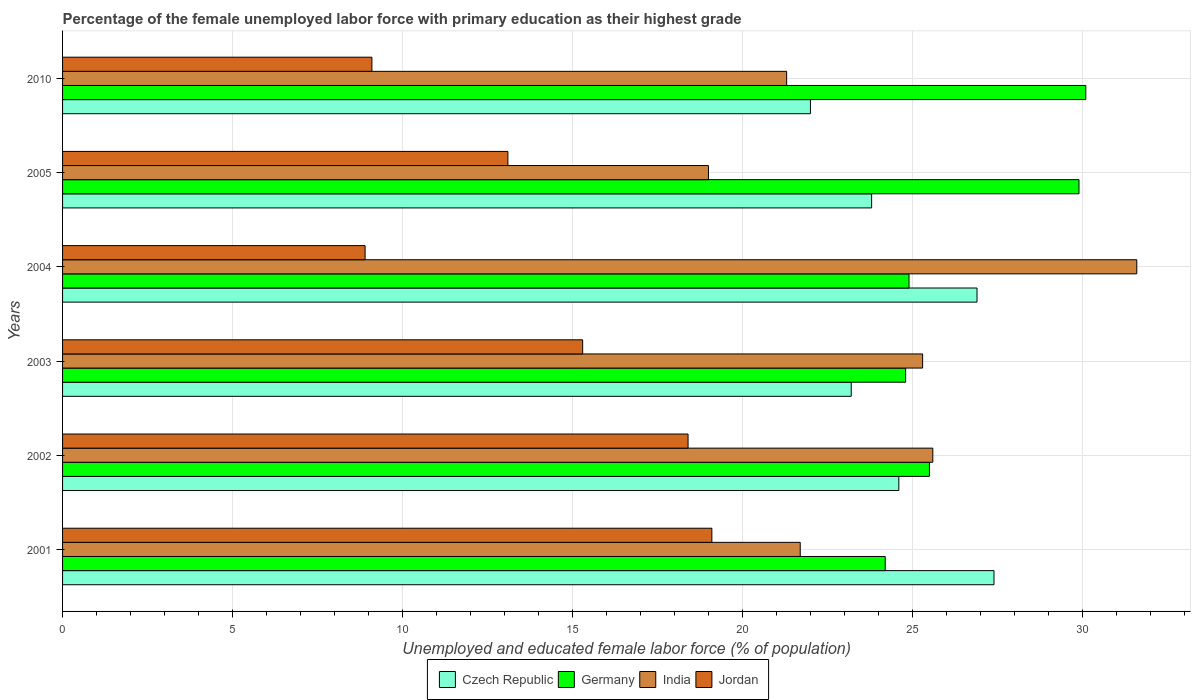How many groups of bars are there?
Your answer should be very brief. 6. Are the number of bars per tick equal to the number of legend labels?
Provide a short and direct response. Yes. Are the number of bars on each tick of the Y-axis equal?
Offer a very short reply. Yes. How many bars are there on the 5th tick from the top?
Offer a very short reply. 4. What is the label of the 1st group of bars from the top?
Your answer should be very brief. 2010. What is the percentage of the unemployed female labor force with primary education in Czech Republic in 2004?
Give a very brief answer. 26.9. Across all years, what is the maximum percentage of the unemployed female labor force with primary education in Germany?
Your answer should be compact. 30.1. In which year was the percentage of the unemployed female labor force with primary education in Germany maximum?
Your response must be concise. 2010. In which year was the percentage of the unemployed female labor force with primary education in India minimum?
Ensure brevity in your answer.  2005. What is the total percentage of the unemployed female labor force with primary education in Jordan in the graph?
Give a very brief answer. 83.9. What is the difference between the percentage of the unemployed female labor force with primary education in Germany in 2001 and that in 2010?
Provide a succinct answer. -5.9. What is the difference between the percentage of the unemployed female labor force with primary education in Czech Republic in 2004 and the percentage of the unemployed female labor force with primary education in Jordan in 2002?
Your answer should be compact. 8.5. What is the average percentage of the unemployed female labor force with primary education in Germany per year?
Offer a terse response. 26.57. In the year 2001, what is the difference between the percentage of the unemployed female labor force with primary education in Germany and percentage of the unemployed female labor force with primary education in Jordan?
Ensure brevity in your answer.  5.1. What is the ratio of the percentage of the unemployed female labor force with primary education in Czech Republic in 2004 to that in 2005?
Offer a very short reply. 1.13. What is the difference between the highest and the second highest percentage of the unemployed female labor force with primary education in Jordan?
Your answer should be very brief. 0.7. What is the difference between the highest and the lowest percentage of the unemployed female labor force with primary education in Germany?
Ensure brevity in your answer.  5.9. In how many years, is the percentage of the unemployed female labor force with primary education in Czech Republic greater than the average percentage of the unemployed female labor force with primary education in Czech Republic taken over all years?
Provide a succinct answer. 2. What does the 4th bar from the top in 2005 represents?
Offer a very short reply. Czech Republic. How many years are there in the graph?
Ensure brevity in your answer.  6. Are the values on the major ticks of X-axis written in scientific E-notation?
Offer a very short reply. No. Does the graph contain grids?
Your answer should be compact. Yes. Where does the legend appear in the graph?
Ensure brevity in your answer.  Bottom center. What is the title of the graph?
Make the answer very short. Percentage of the female unemployed labor force with primary education as their highest grade. What is the label or title of the X-axis?
Provide a succinct answer. Unemployed and educated female labor force (% of population). What is the Unemployed and educated female labor force (% of population) in Czech Republic in 2001?
Your answer should be very brief. 27.4. What is the Unemployed and educated female labor force (% of population) in Germany in 2001?
Ensure brevity in your answer.  24.2. What is the Unemployed and educated female labor force (% of population) in India in 2001?
Your answer should be very brief. 21.7. What is the Unemployed and educated female labor force (% of population) in Jordan in 2001?
Your answer should be compact. 19.1. What is the Unemployed and educated female labor force (% of population) of Czech Republic in 2002?
Your answer should be very brief. 24.6. What is the Unemployed and educated female labor force (% of population) of Germany in 2002?
Give a very brief answer. 25.5. What is the Unemployed and educated female labor force (% of population) of India in 2002?
Give a very brief answer. 25.6. What is the Unemployed and educated female labor force (% of population) in Jordan in 2002?
Give a very brief answer. 18.4. What is the Unemployed and educated female labor force (% of population) in Czech Republic in 2003?
Provide a short and direct response. 23.2. What is the Unemployed and educated female labor force (% of population) in Germany in 2003?
Give a very brief answer. 24.8. What is the Unemployed and educated female labor force (% of population) of India in 2003?
Make the answer very short. 25.3. What is the Unemployed and educated female labor force (% of population) of Jordan in 2003?
Provide a short and direct response. 15.3. What is the Unemployed and educated female labor force (% of population) of Czech Republic in 2004?
Keep it short and to the point. 26.9. What is the Unemployed and educated female labor force (% of population) in Germany in 2004?
Offer a terse response. 24.9. What is the Unemployed and educated female labor force (% of population) in India in 2004?
Make the answer very short. 31.6. What is the Unemployed and educated female labor force (% of population) of Jordan in 2004?
Ensure brevity in your answer.  8.9. What is the Unemployed and educated female labor force (% of population) of Czech Republic in 2005?
Give a very brief answer. 23.8. What is the Unemployed and educated female labor force (% of population) of Germany in 2005?
Offer a very short reply. 29.9. What is the Unemployed and educated female labor force (% of population) in India in 2005?
Your response must be concise. 19. What is the Unemployed and educated female labor force (% of population) of Jordan in 2005?
Your answer should be compact. 13.1. What is the Unemployed and educated female labor force (% of population) in Germany in 2010?
Provide a succinct answer. 30.1. What is the Unemployed and educated female labor force (% of population) in India in 2010?
Your answer should be very brief. 21.3. What is the Unemployed and educated female labor force (% of population) of Jordan in 2010?
Make the answer very short. 9.1. Across all years, what is the maximum Unemployed and educated female labor force (% of population) in Czech Republic?
Offer a very short reply. 27.4. Across all years, what is the maximum Unemployed and educated female labor force (% of population) in Germany?
Ensure brevity in your answer.  30.1. Across all years, what is the maximum Unemployed and educated female labor force (% of population) in India?
Provide a succinct answer. 31.6. Across all years, what is the maximum Unemployed and educated female labor force (% of population) of Jordan?
Make the answer very short. 19.1. Across all years, what is the minimum Unemployed and educated female labor force (% of population) in Germany?
Your answer should be compact. 24.2. Across all years, what is the minimum Unemployed and educated female labor force (% of population) in India?
Offer a very short reply. 19. Across all years, what is the minimum Unemployed and educated female labor force (% of population) of Jordan?
Your answer should be very brief. 8.9. What is the total Unemployed and educated female labor force (% of population) of Czech Republic in the graph?
Make the answer very short. 147.9. What is the total Unemployed and educated female labor force (% of population) of Germany in the graph?
Provide a short and direct response. 159.4. What is the total Unemployed and educated female labor force (% of population) in India in the graph?
Provide a short and direct response. 144.5. What is the total Unemployed and educated female labor force (% of population) in Jordan in the graph?
Ensure brevity in your answer.  83.9. What is the difference between the Unemployed and educated female labor force (% of population) of Czech Republic in 2001 and that in 2002?
Keep it short and to the point. 2.8. What is the difference between the Unemployed and educated female labor force (% of population) in Germany in 2001 and that in 2002?
Your answer should be compact. -1.3. What is the difference between the Unemployed and educated female labor force (% of population) in Jordan in 2001 and that in 2002?
Provide a short and direct response. 0.7. What is the difference between the Unemployed and educated female labor force (% of population) in Czech Republic in 2001 and that in 2003?
Make the answer very short. 4.2. What is the difference between the Unemployed and educated female labor force (% of population) in India in 2001 and that in 2003?
Give a very brief answer. -3.6. What is the difference between the Unemployed and educated female labor force (% of population) in Germany in 2001 and that in 2004?
Your answer should be very brief. -0.7. What is the difference between the Unemployed and educated female labor force (% of population) in Jordan in 2001 and that in 2004?
Make the answer very short. 10.2. What is the difference between the Unemployed and educated female labor force (% of population) of Czech Republic in 2001 and that in 2005?
Provide a short and direct response. 3.6. What is the difference between the Unemployed and educated female labor force (% of population) in Germany in 2001 and that in 2005?
Your answer should be compact. -5.7. What is the difference between the Unemployed and educated female labor force (% of population) in India in 2001 and that in 2005?
Make the answer very short. 2.7. What is the difference between the Unemployed and educated female labor force (% of population) in Czech Republic in 2001 and that in 2010?
Provide a short and direct response. 5.4. What is the difference between the Unemployed and educated female labor force (% of population) of Germany in 2001 and that in 2010?
Your answer should be compact. -5.9. What is the difference between the Unemployed and educated female labor force (% of population) of India in 2001 and that in 2010?
Your answer should be compact. 0.4. What is the difference between the Unemployed and educated female labor force (% of population) of Czech Republic in 2002 and that in 2003?
Your answer should be very brief. 1.4. What is the difference between the Unemployed and educated female labor force (% of population) in India in 2002 and that in 2003?
Your answer should be compact. 0.3. What is the difference between the Unemployed and educated female labor force (% of population) in Jordan in 2002 and that in 2003?
Offer a very short reply. 3.1. What is the difference between the Unemployed and educated female labor force (% of population) in Czech Republic in 2002 and that in 2004?
Give a very brief answer. -2.3. What is the difference between the Unemployed and educated female labor force (% of population) of Jordan in 2002 and that in 2004?
Offer a terse response. 9.5. What is the difference between the Unemployed and educated female labor force (% of population) of Czech Republic in 2002 and that in 2005?
Keep it short and to the point. 0.8. What is the difference between the Unemployed and educated female labor force (% of population) of Jordan in 2002 and that in 2005?
Provide a short and direct response. 5.3. What is the difference between the Unemployed and educated female labor force (% of population) in Germany in 2002 and that in 2010?
Your answer should be compact. -4.6. What is the difference between the Unemployed and educated female labor force (% of population) in Jordan in 2002 and that in 2010?
Give a very brief answer. 9.3. What is the difference between the Unemployed and educated female labor force (% of population) of Germany in 2003 and that in 2004?
Make the answer very short. -0.1. What is the difference between the Unemployed and educated female labor force (% of population) in Jordan in 2003 and that in 2004?
Provide a succinct answer. 6.4. What is the difference between the Unemployed and educated female labor force (% of population) of Germany in 2003 and that in 2005?
Offer a terse response. -5.1. What is the difference between the Unemployed and educated female labor force (% of population) of India in 2003 and that in 2010?
Offer a very short reply. 4. What is the difference between the Unemployed and educated female labor force (% of population) of Germany in 2004 and that in 2005?
Your answer should be compact. -5. What is the difference between the Unemployed and educated female labor force (% of population) in India in 2004 and that in 2005?
Ensure brevity in your answer.  12.6. What is the difference between the Unemployed and educated female labor force (% of population) of Germany in 2004 and that in 2010?
Give a very brief answer. -5.2. What is the difference between the Unemployed and educated female labor force (% of population) in Jordan in 2004 and that in 2010?
Keep it short and to the point. -0.2. What is the difference between the Unemployed and educated female labor force (% of population) of Czech Republic in 2005 and that in 2010?
Keep it short and to the point. 1.8. What is the difference between the Unemployed and educated female labor force (% of population) in Czech Republic in 2001 and the Unemployed and educated female labor force (% of population) in India in 2002?
Your response must be concise. 1.8. What is the difference between the Unemployed and educated female labor force (% of population) of Germany in 2001 and the Unemployed and educated female labor force (% of population) of Jordan in 2002?
Provide a succinct answer. 5.8. What is the difference between the Unemployed and educated female labor force (% of population) in India in 2001 and the Unemployed and educated female labor force (% of population) in Jordan in 2002?
Your answer should be compact. 3.3. What is the difference between the Unemployed and educated female labor force (% of population) in Czech Republic in 2001 and the Unemployed and educated female labor force (% of population) in Germany in 2003?
Your answer should be very brief. 2.6. What is the difference between the Unemployed and educated female labor force (% of population) in Czech Republic in 2001 and the Unemployed and educated female labor force (% of population) in India in 2003?
Offer a very short reply. 2.1. What is the difference between the Unemployed and educated female labor force (% of population) in Germany in 2001 and the Unemployed and educated female labor force (% of population) in India in 2003?
Provide a succinct answer. -1.1. What is the difference between the Unemployed and educated female labor force (% of population) of India in 2001 and the Unemployed and educated female labor force (% of population) of Jordan in 2003?
Make the answer very short. 6.4. What is the difference between the Unemployed and educated female labor force (% of population) of Czech Republic in 2001 and the Unemployed and educated female labor force (% of population) of Jordan in 2004?
Give a very brief answer. 18.5. What is the difference between the Unemployed and educated female labor force (% of population) in Germany in 2001 and the Unemployed and educated female labor force (% of population) in India in 2004?
Ensure brevity in your answer.  -7.4. What is the difference between the Unemployed and educated female labor force (% of population) of Germany in 2001 and the Unemployed and educated female labor force (% of population) of Jordan in 2004?
Make the answer very short. 15.3. What is the difference between the Unemployed and educated female labor force (% of population) in Czech Republic in 2001 and the Unemployed and educated female labor force (% of population) in Germany in 2005?
Provide a short and direct response. -2.5. What is the difference between the Unemployed and educated female labor force (% of population) in Germany in 2001 and the Unemployed and educated female labor force (% of population) in Jordan in 2005?
Offer a very short reply. 11.1. What is the difference between the Unemployed and educated female labor force (% of population) of Czech Republic in 2001 and the Unemployed and educated female labor force (% of population) of India in 2010?
Offer a terse response. 6.1. What is the difference between the Unemployed and educated female labor force (% of population) of Czech Republic in 2001 and the Unemployed and educated female labor force (% of population) of Jordan in 2010?
Your answer should be compact. 18.3. What is the difference between the Unemployed and educated female labor force (% of population) in Germany in 2001 and the Unemployed and educated female labor force (% of population) in India in 2010?
Provide a succinct answer. 2.9. What is the difference between the Unemployed and educated female labor force (% of population) in Germany in 2001 and the Unemployed and educated female labor force (% of population) in Jordan in 2010?
Provide a short and direct response. 15.1. What is the difference between the Unemployed and educated female labor force (% of population) of Czech Republic in 2002 and the Unemployed and educated female labor force (% of population) of Germany in 2003?
Make the answer very short. -0.2. What is the difference between the Unemployed and educated female labor force (% of population) of Czech Republic in 2002 and the Unemployed and educated female labor force (% of population) of India in 2003?
Your answer should be compact. -0.7. What is the difference between the Unemployed and educated female labor force (% of population) of Germany in 2002 and the Unemployed and educated female labor force (% of population) of India in 2003?
Provide a succinct answer. 0.2. What is the difference between the Unemployed and educated female labor force (% of population) of India in 2002 and the Unemployed and educated female labor force (% of population) of Jordan in 2003?
Your response must be concise. 10.3. What is the difference between the Unemployed and educated female labor force (% of population) of Czech Republic in 2002 and the Unemployed and educated female labor force (% of population) of India in 2004?
Your response must be concise. -7. What is the difference between the Unemployed and educated female labor force (% of population) in Czech Republic in 2002 and the Unemployed and educated female labor force (% of population) in Jordan in 2004?
Provide a short and direct response. 15.7. What is the difference between the Unemployed and educated female labor force (% of population) of Germany in 2002 and the Unemployed and educated female labor force (% of population) of India in 2004?
Make the answer very short. -6.1. What is the difference between the Unemployed and educated female labor force (% of population) in Czech Republic in 2002 and the Unemployed and educated female labor force (% of population) in Germany in 2005?
Provide a short and direct response. -5.3. What is the difference between the Unemployed and educated female labor force (% of population) in Czech Republic in 2002 and the Unemployed and educated female labor force (% of population) in Jordan in 2005?
Give a very brief answer. 11.5. What is the difference between the Unemployed and educated female labor force (% of population) of Germany in 2002 and the Unemployed and educated female labor force (% of population) of Jordan in 2005?
Provide a short and direct response. 12.4. What is the difference between the Unemployed and educated female labor force (% of population) of Germany in 2002 and the Unemployed and educated female labor force (% of population) of Jordan in 2010?
Your answer should be very brief. 16.4. What is the difference between the Unemployed and educated female labor force (% of population) in Czech Republic in 2003 and the Unemployed and educated female labor force (% of population) in India in 2004?
Provide a succinct answer. -8.4. What is the difference between the Unemployed and educated female labor force (% of population) in Czech Republic in 2003 and the Unemployed and educated female labor force (% of population) in Jordan in 2004?
Ensure brevity in your answer.  14.3. What is the difference between the Unemployed and educated female labor force (% of population) in Germany in 2003 and the Unemployed and educated female labor force (% of population) in India in 2004?
Provide a succinct answer. -6.8. What is the difference between the Unemployed and educated female labor force (% of population) of India in 2003 and the Unemployed and educated female labor force (% of population) of Jordan in 2004?
Make the answer very short. 16.4. What is the difference between the Unemployed and educated female labor force (% of population) of Czech Republic in 2003 and the Unemployed and educated female labor force (% of population) of Jordan in 2005?
Your answer should be compact. 10.1. What is the difference between the Unemployed and educated female labor force (% of population) of Germany in 2003 and the Unemployed and educated female labor force (% of population) of India in 2005?
Your answer should be compact. 5.8. What is the difference between the Unemployed and educated female labor force (% of population) of Czech Republic in 2003 and the Unemployed and educated female labor force (% of population) of Germany in 2010?
Keep it short and to the point. -6.9. What is the difference between the Unemployed and educated female labor force (% of population) of Czech Republic in 2003 and the Unemployed and educated female labor force (% of population) of India in 2010?
Ensure brevity in your answer.  1.9. What is the difference between the Unemployed and educated female labor force (% of population) of Germany in 2003 and the Unemployed and educated female labor force (% of population) of India in 2010?
Keep it short and to the point. 3.5. What is the difference between the Unemployed and educated female labor force (% of population) of India in 2003 and the Unemployed and educated female labor force (% of population) of Jordan in 2010?
Offer a very short reply. 16.2. What is the difference between the Unemployed and educated female labor force (% of population) of Czech Republic in 2004 and the Unemployed and educated female labor force (% of population) of India in 2005?
Keep it short and to the point. 7.9. What is the difference between the Unemployed and educated female labor force (% of population) in India in 2004 and the Unemployed and educated female labor force (% of population) in Jordan in 2005?
Your answer should be very brief. 18.5. What is the difference between the Unemployed and educated female labor force (% of population) of Czech Republic in 2004 and the Unemployed and educated female labor force (% of population) of Germany in 2010?
Keep it short and to the point. -3.2. What is the difference between the Unemployed and educated female labor force (% of population) in Germany in 2004 and the Unemployed and educated female labor force (% of population) in India in 2010?
Your answer should be compact. 3.6. What is the difference between the Unemployed and educated female labor force (% of population) in Germany in 2004 and the Unemployed and educated female labor force (% of population) in Jordan in 2010?
Give a very brief answer. 15.8. What is the difference between the Unemployed and educated female labor force (% of population) of Czech Republic in 2005 and the Unemployed and educated female labor force (% of population) of Germany in 2010?
Provide a short and direct response. -6.3. What is the difference between the Unemployed and educated female labor force (% of population) of Germany in 2005 and the Unemployed and educated female labor force (% of population) of Jordan in 2010?
Offer a very short reply. 20.8. What is the average Unemployed and educated female labor force (% of population) in Czech Republic per year?
Offer a very short reply. 24.65. What is the average Unemployed and educated female labor force (% of population) of Germany per year?
Offer a very short reply. 26.57. What is the average Unemployed and educated female labor force (% of population) in India per year?
Your response must be concise. 24.08. What is the average Unemployed and educated female labor force (% of population) of Jordan per year?
Your answer should be compact. 13.98. In the year 2001, what is the difference between the Unemployed and educated female labor force (% of population) in Czech Republic and Unemployed and educated female labor force (% of population) in India?
Give a very brief answer. 5.7. In the year 2001, what is the difference between the Unemployed and educated female labor force (% of population) of Germany and Unemployed and educated female labor force (% of population) of India?
Give a very brief answer. 2.5. In the year 2001, what is the difference between the Unemployed and educated female labor force (% of population) in India and Unemployed and educated female labor force (% of population) in Jordan?
Provide a short and direct response. 2.6. In the year 2002, what is the difference between the Unemployed and educated female labor force (% of population) of Czech Republic and Unemployed and educated female labor force (% of population) of Germany?
Keep it short and to the point. -0.9. In the year 2002, what is the difference between the Unemployed and educated female labor force (% of population) in Czech Republic and Unemployed and educated female labor force (% of population) in India?
Offer a terse response. -1. In the year 2002, what is the difference between the Unemployed and educated female labor force (% of population) of Czech Republic and Unemployed and educated female labor force (% of population) of Jordan?
Your response must be concise. 6.2. In the year 2002, what is the difference between the Unemployed and educated female labor force (% of population) of Germany and Unemployed and educated female labor force (% of population) of India?
Keep it short and to the point. -0.1. In the year 2002, what is the difference between the Unemployed and educated female labor force (% of population) in India and Unemployed and educated female labor force (% of population) in Jordan?
Give a very brief answer. 7.2. In the year 2003, what is the difference between the Unemployed and educated female labor force (% of population) of Czech Republic and Unemployed and educated female labor force (% of population) of Germany?
Make the answer very short. -1.6. In the year 2003, what is the difference between the Unemployed and educated female labor force (% of population) in Czech Republic and Unemployed and educated female labor force (% of population) in Jordan?
Your response must be concise. 7.9. In the year 2004, what is the difference between the Unemployed and educated female labor force (% of population) in Czech Republic and Unemployed and educated female labor force (% of population) in Germany?
Offer a very short reply. 2. In the year 2004, what is the difference between the Unemployed and educated female labor force (% of population) of Germany and Unemployed and educated female labor force (% of population) of India?
Your response must be concise. -6.7. In the year 2004, what is the difference between the Unemployed and educated female labor force (% of population) in Germany and Unemployed and educated female labor force (% of population) in Jordan?
Provide a succinct answer. 16. In the year 2004, what is the difference between the Unemployed and educated female labor force (% of population) in India and Unemployed and educated female labor force (% of population) in Jordan?
Your answer should be compact. 22.7. In the year 2005, what is the difference between the Unemployed and educated female labor force (% of population) of Germany and Unemployed and educated female labor force (% of population) of India?
Provide a short and direct response. 10.9. In the year 2010, what is the difference between the Unemployed and educated female labor force (% of population) of Czech Republic and Unemployed and educated female labor force (% of population) of Germany?
Ensure brevity in your answer.  -8.1. In the year 2010, what is the difference between the Unemployed and educated female labor force (% of population) of Czech Republic and Unemployed and educated female labor force (% of population) of India?
Offer a terse response. 0.7. In the year 2010, what is the difference between the Unemployed and educated female labor force (% of population) of Germany and Unemployed and educated female labor force (% of population) of India?
Provide a succinct answer. 8.8. What is the ratio of the Unemployed and educated female labor force (% of population) in Czech Republic in 2001 to that in 2002?
Your response must be concise. 1.11. What is the ratio of the Unemployed and educated female labor force (% of population) of Germany in 2001 to that in 2002?
Provide a short and direct response. 0.95. What is the ratio of the Unemployed and educated female labor force (% of population) in India in 2001 to that in 2002?
Your response must be concise. 0.85. What is the ratio of the Unemployed and educated female labor force (% of population) in Jordan in 2001 to that in 2002?
Give a very brief answer. 1.04. What is the ratio of the Unemployed and educated female labor force (% of population) in Czech Republic in 2001 to that in 2003?
Offer a terse response. 1.18. What is the ratio of the Unemployed and educated female labor force (% of population) of Germany in 2001 to that in 2003?
Ensure brevity in your answer.  0.98. What is the ratio of the Unemployed and educated female labor force (% of population) in India in 2001 to that in 2003?
Make the answer very short. 0.86. What is the ratio of the Unemployed and educated female labor force (% of population) in Jordan in 2001 to that in 2003?
Your response must be concise. 1.25. What is the ratio of the Unemployed and educated female labor force (% of population) of Czech Republic in 2001 to that in 2004?
Your answer should be compact. 1.02. What is the ratio of the Unemployed and educated female labor force (% of population) of Germany in 2001 to that in 2004?
Your answer should be compact. 0.97. What is the ratio of the Unemployed and educated female labor force (% of population) of India in 2001 to that in 2004?
Your answer should be compact. 0.69. What is the ratio of the Unemployed and educated female labor force (% of population) in Jordan in 2001 to that in 2004?
Provide a short and direct response. 2.15. What is the ratio of the Unemployed and educated female labor force (% of population) in Czech Republic in 2001 to that in 2005?
Ensure brevity in your answer.  1.15. What is the ratio of the Unemployed and educated female labor force (% of population) in Germany in 2001 to that in 2005?
Give a very brief answer. 0.81. What is the ratio of the Unemployed and educated female labor force (% of population) of India in 2001 to that in 2005?
Keep it short and to the point. 1.14. What is the ratio of the Unemployed and educated female labor force (% of population) of Jordan in 2001 to that in 2005?
Offer a very short reply. 1.46. What is the ratio of the Unemployed and educated female labor force (% of population) in Czech Republic in 2001 to that in 2010?
Provide a short and direct response. 1.25. What is the ratio of the Unemployed and educated female labor force (% of population) of Germany in 2001 to that in 2010?
Offer a terse response. 0.8. What is the ratio of the Unemployed and educated female labor force (% of population) in India in 2001 to that in 2010?
Provide a short and direct response. 1.02. What is the ratio of the Unemployed and educated female labor force (% of population) in Jordan in 2001 to that in 2010?
Your response must be concise. 2.1. What is the ratio of the Unemployed and educated female labor force (% of population) of Czech Republic in 2002 to that in 2003?
Provide a short and direct response. 1.06. What is the ratio of the Unemployed and educated female labor force (% of population) of Germany in 2002 to that in 2003?
Keep it short and to the point. 1.03. What is the ratio of the Unemployed and educated female labor force (% of population) in India in 2002 to that in 2003?
Your answer should be very brief. 1.01. What is the ratio of the Unemployed and educated female labor force (% of population) in Jordan in 2002 to that in 2003?
Offer a very short reply. 1.2. What is the ratio of the Unemployed and educated female labor force (% of population) in Czech Republic in 2002 to that in 2004?
Your answer should be very brief. 0.91. What is the ratio of the Unemployed and educated female labor force (% of population) in Germany in 2002 to that in 2004?
Make the answer very short. 1.02. What is the ratio of the Unemployed and educated female labor force (% of population) of India in 2002 to that in 2004?
Make the answer very short. 0.81. What is the ratio of the Unemployed and educated female labor force (% of population) in Jordan in 2002 to that in 2004?
Keep it short and to the point. 2.07. What is the ratio of the Unemployed and educated female labor force (% of population) in Czech Republic in 2002 to that in 2005?
Provide a succinct answer. 1.03. What is the ratio of the Unemployed and educated female labor force (% of population) of Germany in 2002 to that in 2005?
Provide a succinct answer. 0.85. What is the ratio of the Unemployed and educated female labor force (% of population) of India in 2002 to that in 2005?
Your answer should be very brief. 1.35. What is the ratio of the Unemployed and educated female labor force (% of population) of Jordan in 2002 to that in 2005?
Keep it short and to the point. 1.4. What is the ratio of the Unemployed and educated female labor force (% of population) of Czech Republic in 2002 to that in 2010?
Your response must be concise. 1.12. What is the ratio of the Unemployed and educated female labor force (% of population) of Germany in 2002 to that in 2010?
Your answer should be compact. 0.85. What is the ratio of the Unemployed and educated female labor force (% of population) of India in 2002 to that in 2010?
Give a very brief answer. 1.2. What is the ratio of the Unemployed and educated female labor force (% of population) in Jordan in 2002 to that in 2010?
Provide a succinct answer. 2.02. What is the ratio of the Unemployed and educated female labor force (% of population) in Czech Republic in 2003 to that in 2004?
Offer a terse response. 0.86. What is the ratio of the Unemployed and educated female labor force (% of population) of India in 2003 to that in 2004?
Give a very brief answer. 0.8. What is the ratio of the Unemployed and educated female labor force (% of population) of Jordan in 2003 to that in 2004?
Offer a terse response. 1.72. What is the ratio of the Unemployed and educated female labor force (% of population) of Czech Republic in 2003 to that in 2005?
Your answer should be compact. 0.97. What is the ratio of the Unemployed and educated female labor force (% of population) of Germany in 2003 to that in 2005?
Your response must be concise. 0.83. What is the ratio of the Unemployed and educated female labor force (% of population) of India in 2003 to that in 2005?
Provide a short and direct response. 1.33. What is the ratio of the Unemployed and educated female labor force (% of population) in Jordan in 2003 to that in 2005?
Provide a succinct answer. 1.17. What is the ratio of the Unemployed and educated female labor force (% of population) in Czech Republic in 2003 to that in 2010?
Your answer should be compact. 1.05. What is the ratio of the Unemployed and educated female labor force (% of population) of Germany in 2003 to that in 2010?
Your answer should be compact. 0.82. What is the ratio of the Unemployed and educated female labor force (% of population) of India in 2003 to that in 2010?
Offer a terse response. 1.19. What is the ratio of the Unemployed and educated female labor force (% of population) of Jordan in 2003 to that in 2010?
Offer a terse response. 1.68. What is the ratio of the Unemployed and educated female labor force (% of population) of Czech Republic in 2004 to that in 2005?
Provide a succinct answer. 1.13. What is the ratio of the Unemployed and educated female labor force (% of population) in Germany in 2004 to that in 2005?
Keep it short and to the point. 0.83. What is the ratio of the Unemployed and educated female labor force (% of population) in India in 2004 to that in 2005?
Provide a short and direct response. 1.66. What is the ratio of the Unemployed and educated female labor force (% of population) of Jordan in 2004 to that in 2005?
Offer a very short reply. 0.68. What is the ratio of the Unemployed and educated female labor force (% of population) in Czech Republic in 2004 to that in 2010?
Offer a very short reply. 1.22. What is the ratio of the Unemployed and educated female labor force (% of population) in Germany in 2004 to that in 2010?
Offer a terse response. 0.83. What is the ratio of the Unemployed and educated female labor force (% of population) in India in 2004 to that in 2010?
Offer a very short reply. 1.48. What is the ratio of the Unemployed and educated female labor force (% of population) in Czech Republic in 2005 to that in 2010?
Keep it short and to the point. 1.08. What is the ratio of the Unemployed and educated female labor force (% of population) of Germany in 2005 to that in 2010?
Provide a short and direct response. 0.99. What is the ratio of the Unemployed and educated female labor force (% of population) in India in 2005 to that in 2010?
Your answer should be compact. 0.89. What is the ratio of the Unemployed and educated female labor force (% of population) of Jordan in 2005 to that in 2010?
Offer a very short reply. 1.44. What is the difference between the highest and the second highest Unemployed and educated female labor force (% of population) in Czech Republic?
Make the answer very short. 0.5. What is the difference between the highest and the second highest Unemployed and educated female labor force (% of population) of India?
Ensure brevity in your answer.  6. What is the difference between the highest and the second highest Unemployed and educated female labor force (% of population) of Jordan?
Your answer should be very brief. 0.7. What is the difference between the highest and the lowest Unemployed and educated female labor force (% of population) of Czech Republic?
Make the answer very short. 5.4. 